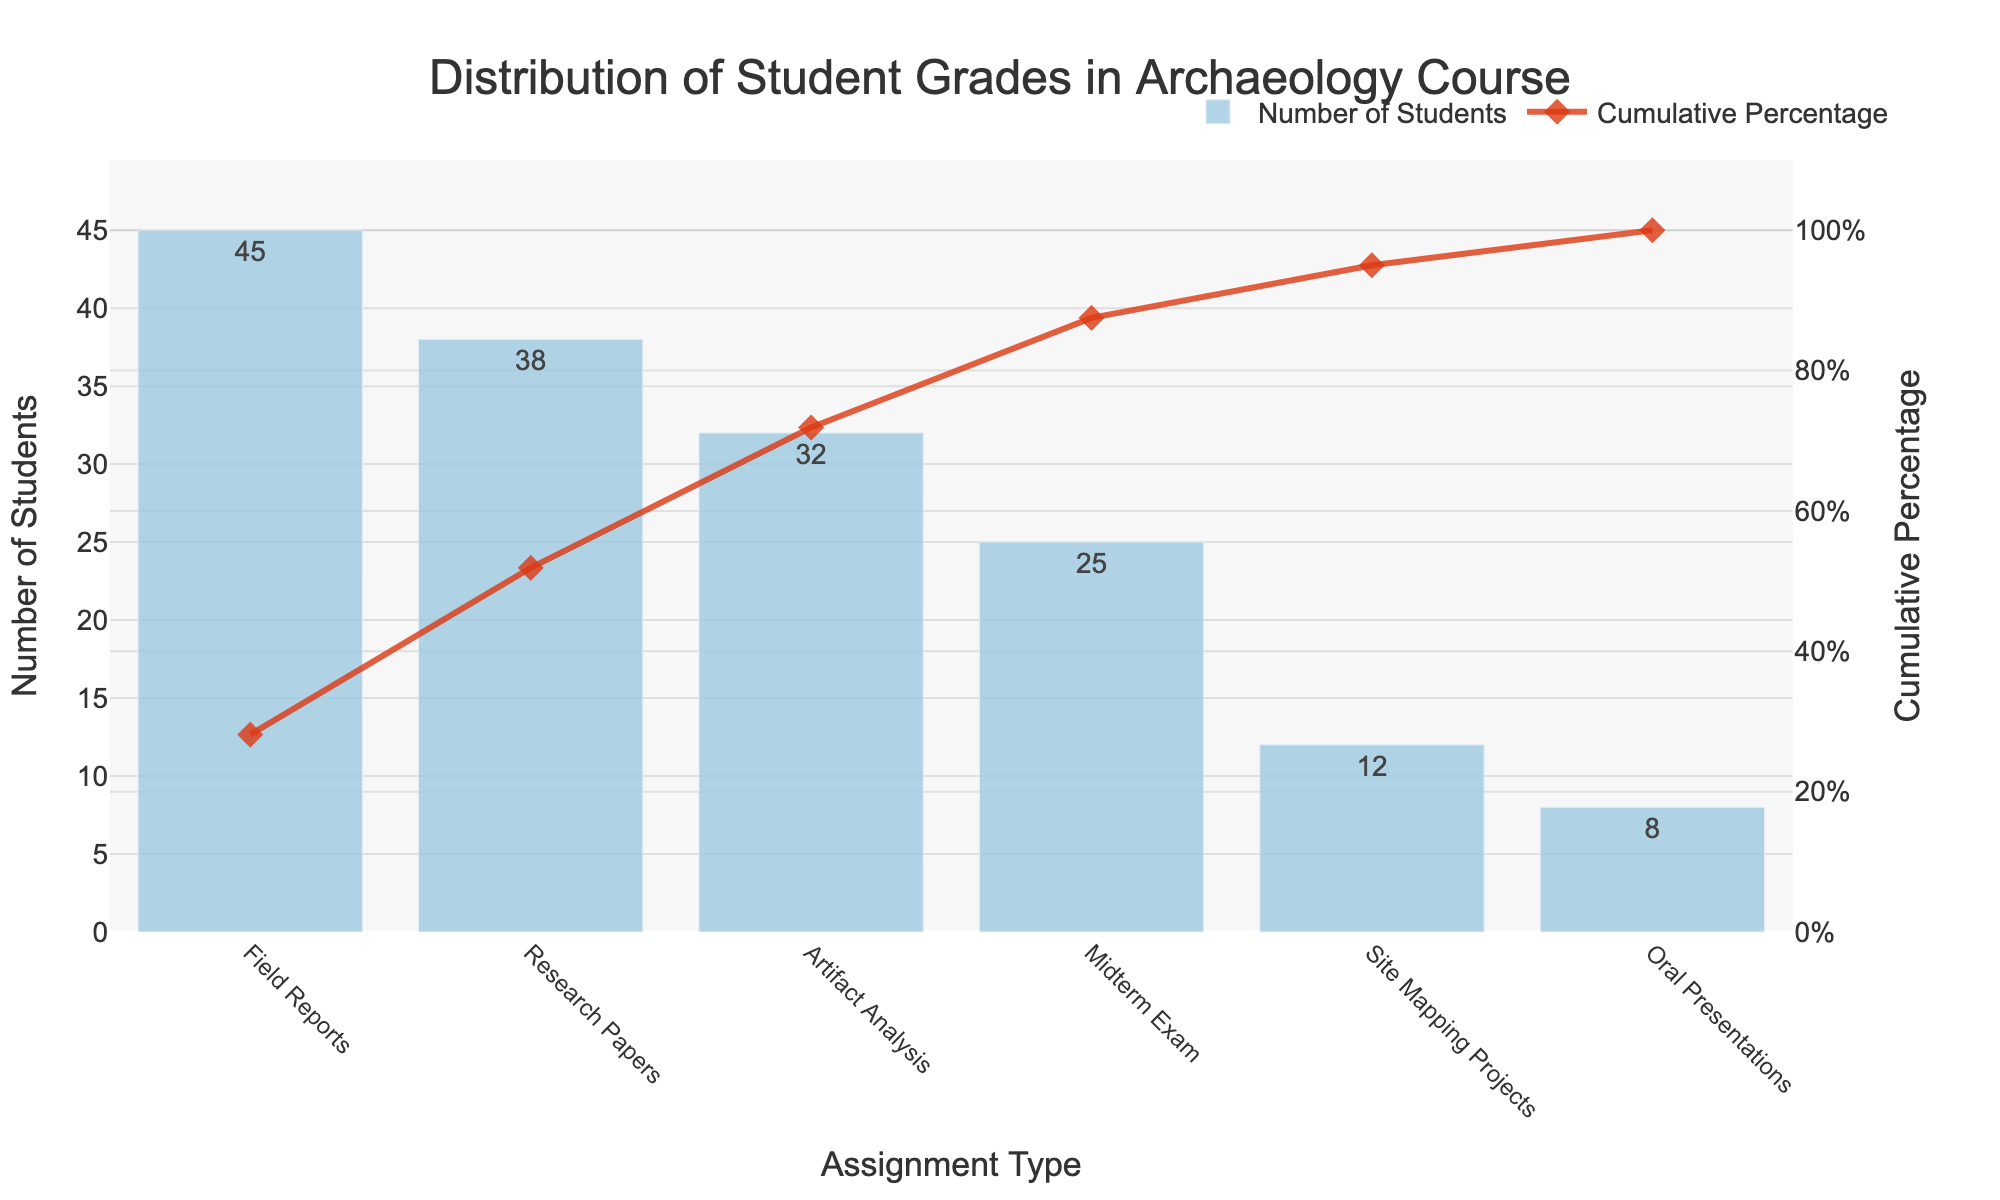What is the title of the chart? The title is usually displayed at the top of the chart, indicating what the visualization is about. Reference the title text in the figure.
Answer: Distribution of Student Grades in Archaeology Course What color are the bars representing the number of students? The bars are represented in a specific color to distinguish data visually. Check the visual properties of the bars in the chart.
Answer: Light blue Which assignment type has the highest number of students? The highest bar represents the assignment type with the most students. Compare the heights of all bars.
Answer: Field Reports What percentage of students have completed artifact analysis and earlier assignments? Add the cumulative percentages up to and including "Artifact Analysis". Reference cumulative percentage values in the chart.
Answer: 71.88% How many students in total have participated in the assignments listed? Sum all the numbers of students shown for each assignment type. Reference the "Number of Students" field across all assignment types.
Answer: 45 + 38 + 32 + 25 + 12 + 8 = 160 What is the cumulative percentage after the Midterm Exam? The cumulative percentage at Midterm Exam is directly noted beside the marker in the line plot. Reference the cumulative percentage noted for this assignment type.
Answer: 87.50% How does the number of students in Oral Presentations compare to those in Field Reports? Compare the heights of the bars representing "Oral Presentations" and "Field Reports".
Answer: Field Reports have more students (45) than Oral Presentations (8) If a student had completed the Field Reports and Research Papers, what cumulative percentage would be achieved? Add the cumulative percentages of "Field Reports" and "Research Papers". Reference cumulative percentages of these assignment types.
Answer: 51.88% What is the difference in the number of students between the assignment type with the highest number and the type with the fewest? Calculate the difference between the highest and lowest student numbers by referring to the bars with maximum and minimum heights.
Answer: 45 (Field Reports) - 8 (Oral Presentations) = 37 What percentage of total assignments does Site Mapping Projects represent? Divide the number of students who did Site Mapping Projects by the total number of students, then multiply by 100. Reference number of students from Site Mapping Projects and the total sum.
Answer: (12 / 160) * 100 ≈ 7.5% 